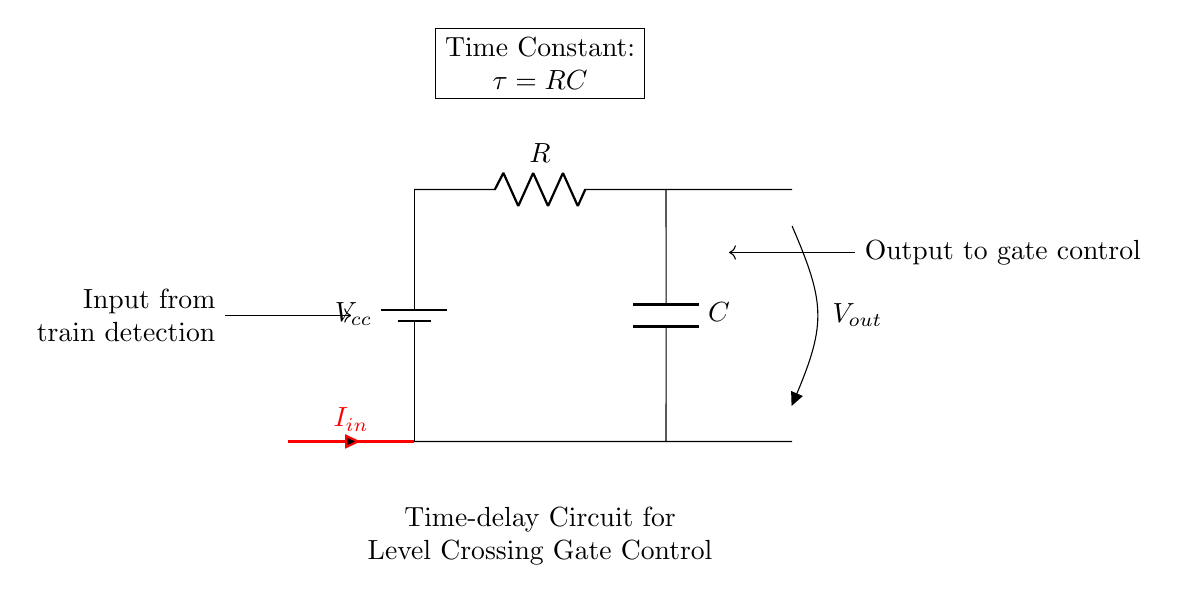What components are present in this circuit? The circuit consists of a battery, resistor, capacitor, and an output voltage node. Each component is explicitly labeled in the diagram.
Answer: battery, resistor, capacitor What does the output voltage represent in this circuit? The output voltage is the voltage drop across the capacitor, which is essential for determining the timing of the gate control signal after the input signal is detected.
Answer: voltage drop across the capacitor What is the purpose of the resistor in this circuit? The resistor limits the current flowing into the capacitor, affecting the charging time and thereby controlling the time-delay in activating the gate mechanism.
Answer: current limiter How is the time constant of this circuit calculated? The time constant, denoted as tau (τ), is calculated using the formula τ equals R times C, where R is the resistance and C is the capacitance. This affects how long the gate control takes to respond.
Answer: RC What happens if the value of the capacitor is increased? Increasing the capacitor value increases the time constant τ, resulting in a longer duration before the gate control is activated. This means the gate will remain closed longer after a train is detected.
Answer: longer delay What is the input current's role in this time-delay circuit? The input current triggers the charging of the capacitor, starting the time delay. Its value affects how quickly the capacitor charges and, in turn, influences the gate control timing.
Answer: triggers charging How does the circuit respond when the input signal stops? When the input signal ceases, the capacitor will begin discharging through the resistor, affecting how quickly the gate control returns to its original state. This process is also governed by the time constant τ.
Answer: capacitor discharges 